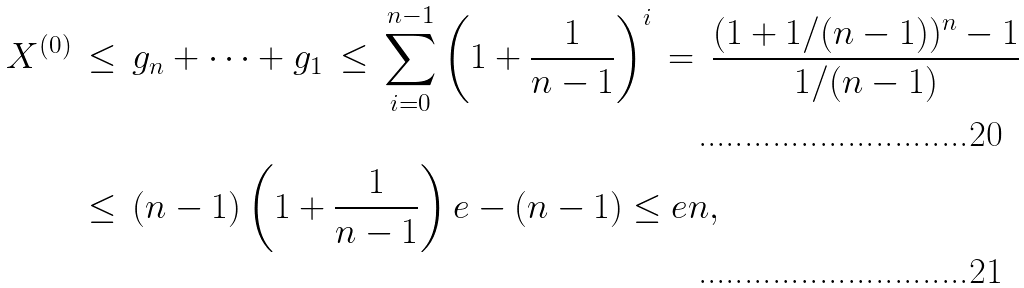<formula> <loc_0><loc_0><loc_500><loc_500>X ^ { ( 0 ) } & \, \leq \, g _ { n } + \dots + g _ { 1 } \, \leq \, \sum _ { i = 0 } ^ { n - 1 } \left ( 1 + \frac { 1 } { n - 1 } \right ) ^ { i } \, = \, \frac { ( 1 + 1 / ( n - 1 ) ) ^ { n } - 1 } { 1 / ( n - 1 ) } \\ & \, \leq \, ( n - 1 ) \left ( 1 + \frac { 1 } { n - 1 } \right ) e - ( n - 1 ) \leq e n ,</formula> 